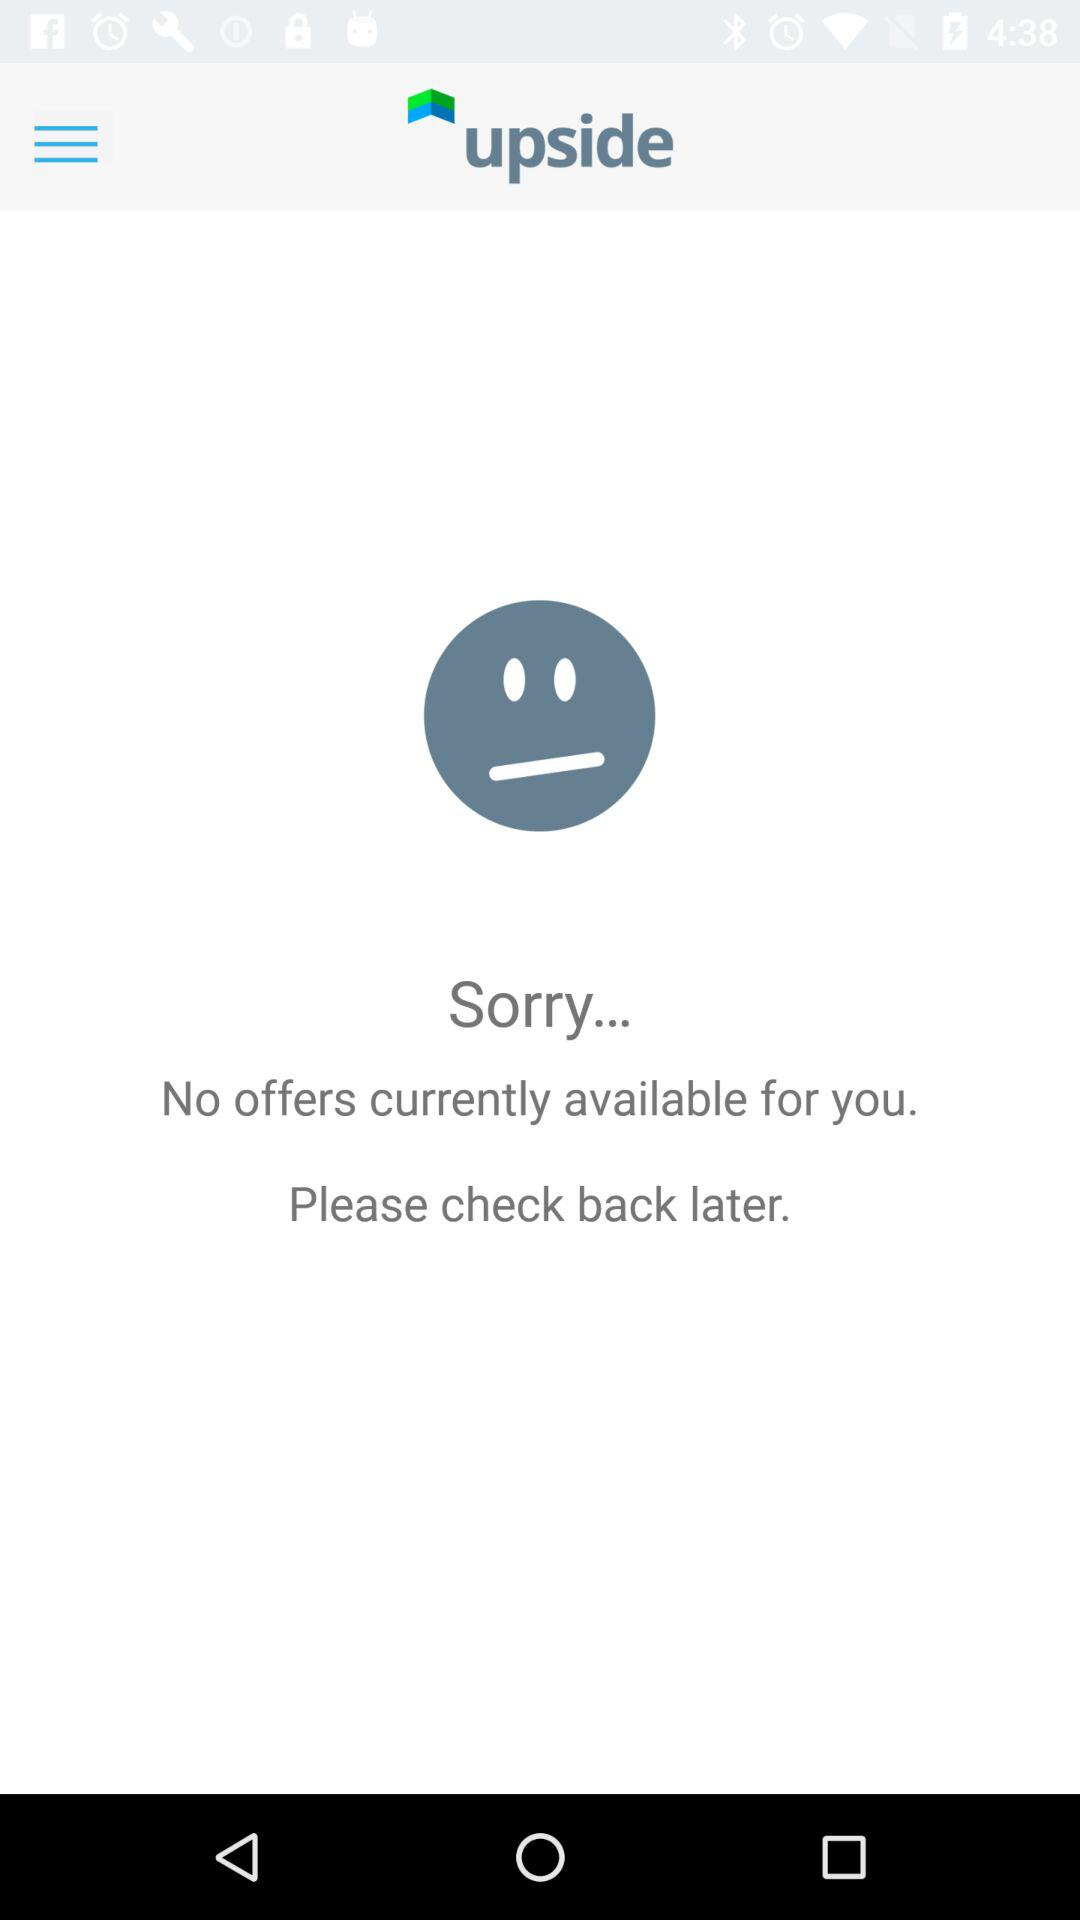Are there any offers available? There are no offers available. 